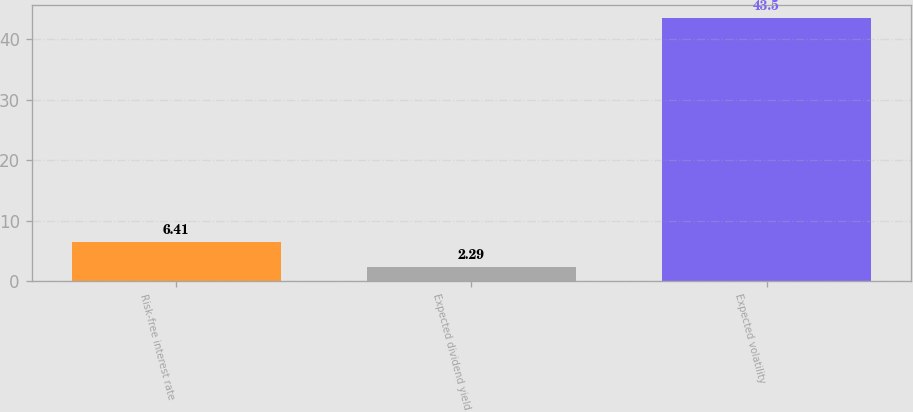<chart> <loc_0><loc_0><loc_500><loc_500><bar_chart><fcel>Risk-free interest rate<fcel>Expected dividend yield<fcel>Expected volatility<nl><fcel>6.41<fcel>2.29<fcel>43.5<nl></chart> 